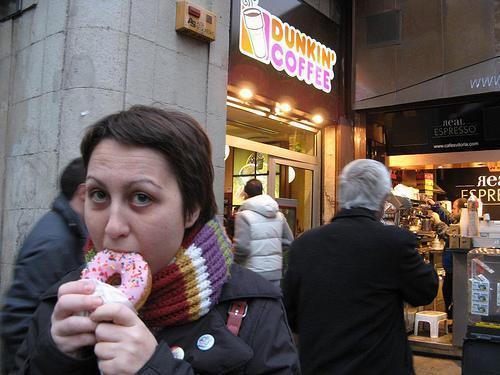What is the woman eating the donut wearing?
Select the accurate answer and provide justification: `Answer: choice
Rationale: srationale.`
Options: Crown, scarf, hat, armor. Answer: scarf.
Rationale: There is only one woman eating a donut and the most prominent piece of clothing is answer a and none of the other answers are present on the woman. 